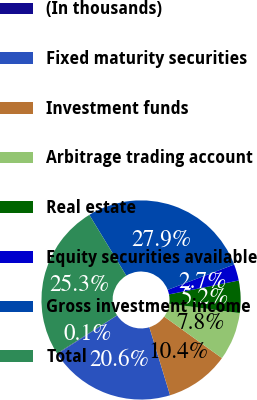<chart> <loc_0><loc_0><loc_500><loc_500><pie_chart><fcel>(In thousands)<fcel>Fixed maturity securities<fcel>Investment funds<fcel>Arbitrage trading account<fcel>Real estate<fcel>Equity securities available<fcel>Gross investment income<fcel>Total<nl><fcel>0.09%<fcel>20.59%<fcel>10.38%<fcel>7.81%<fcel>5.24%<fcel>2.66%<fcel>27.9%<fcel>25.33%<nl></chart> 